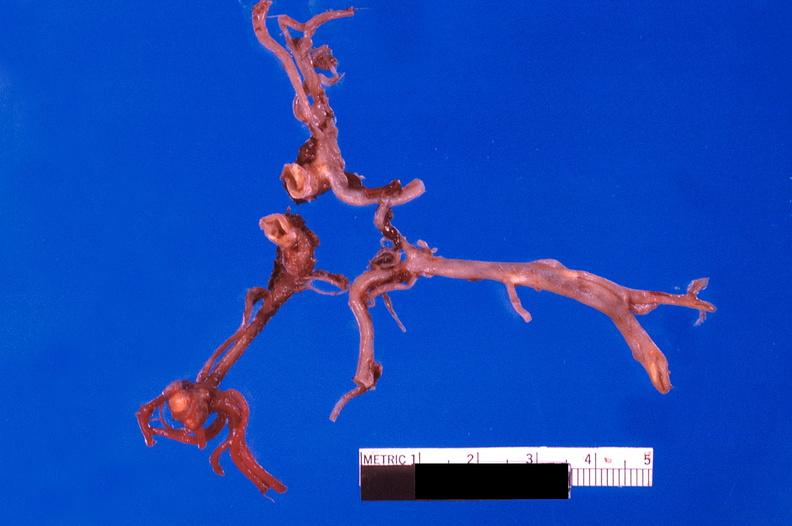s cardiovascular present?
Answer the question using a single word or phrase. Yes 